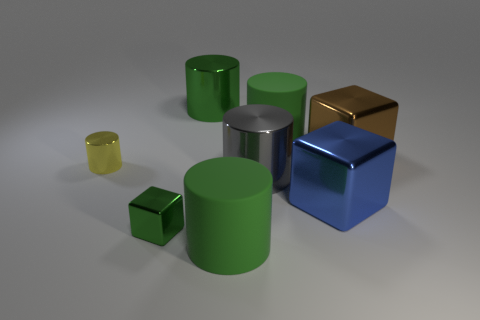How many green cylinders must be subtracted to get 1 green cylinders? 2 Subtract all tiny metal cubes. How many cubes are left? 2 Subtract all yellow cylinders. How many cylinders are left? 4 Subtract 4 cylinders. How many cylinders are left? 1 Add 1 small cyan rubber things. How many objects exist? 9 Subtract 1 blue cubes. How many objects are left? 7 Subtract all cylinders. How many objects are left? 3 Subtract all yellow cubes. Subtract all cyan spheres. How many cubes are left? 3 Subtract all brown cylinders. How many cyan blocks are left? 0 Subtract all large green metallic cylinders. Subtract all green metal cubes. How many objects are left? 6 